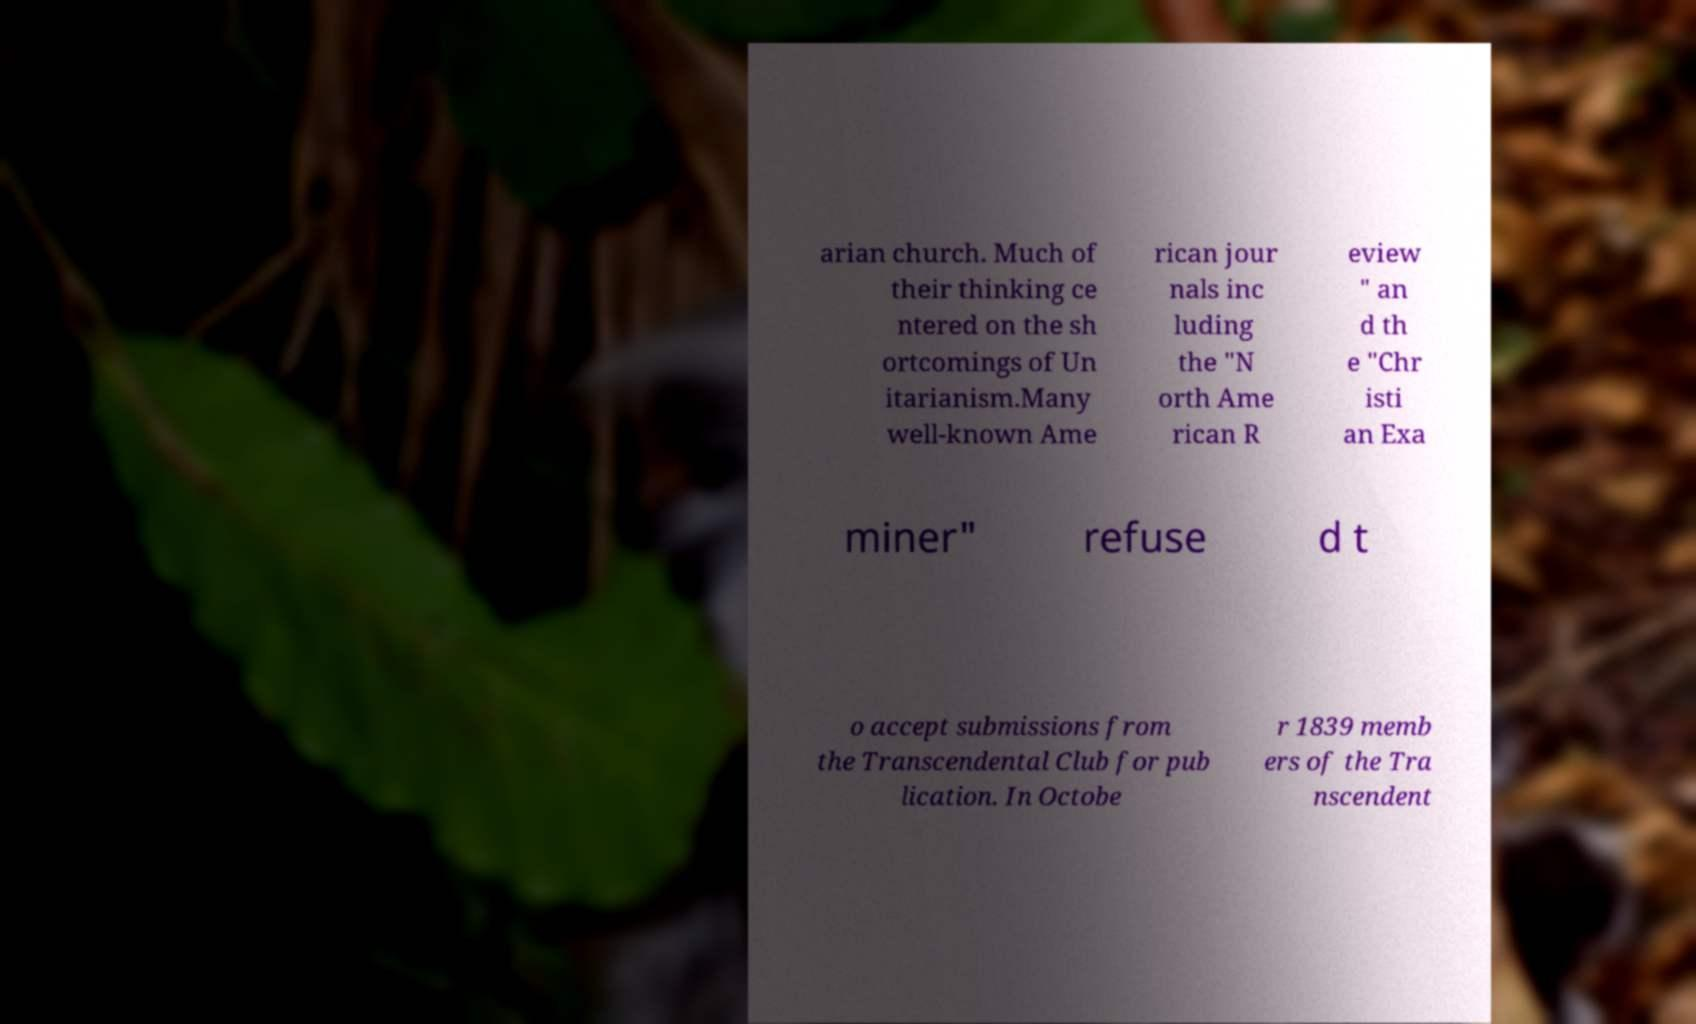Could you extract and type out the text from this image? arian church. Much of their thinking ce ntered on the sh ortcomings of Un itarianism.Many well-known Ame rican jour nals inc luding the "N orth Ame rican R eview " an d th e "Chr isti an Exa miner" refuse d t o accept submissions from the Transcendental Club for pub lication. In Octobe r 1839 memb ers of the Tra nscendent 